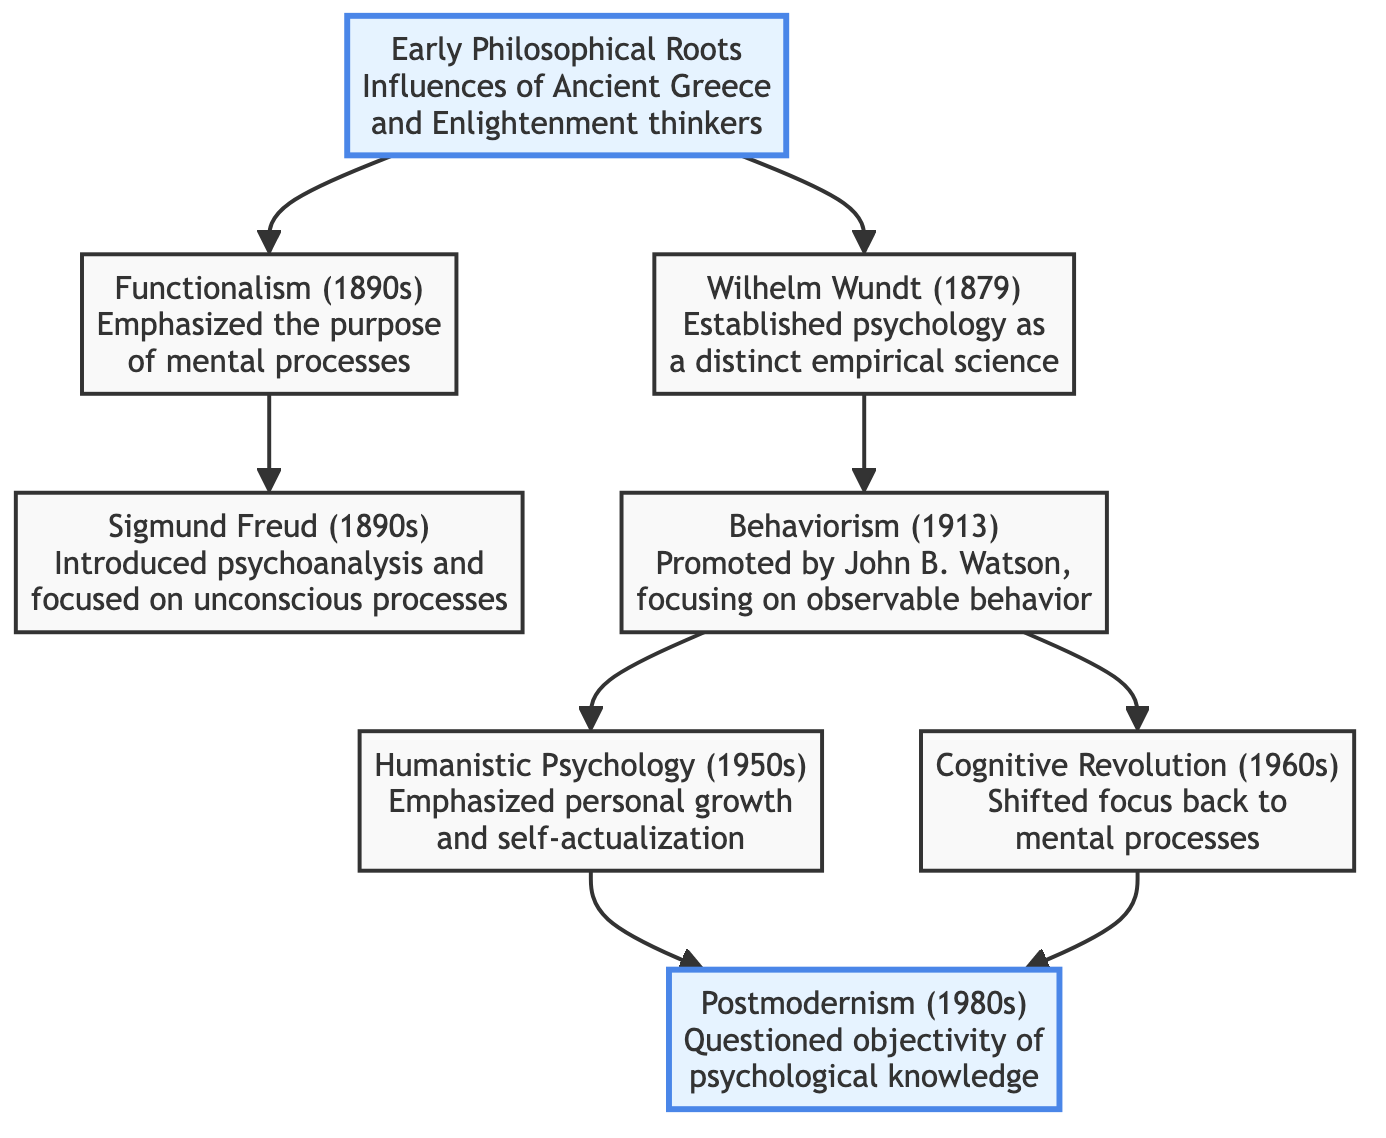What are the two branches stemming from Early Philosophical Roots? The diagram shows two edges coming out of the node "Early Philosophical Roots," connecting to the nodes "Wilhelm Wundt (1879)" and "Functionalism (1890s)."
Answer: Wilhelm Wundt (1879), Functionalism (1890s) How many nodes are there in the diagram? By counting the individual nodes listed in the diagram, we find a total of 8 distinct nodes: Early Philosophical Roots, Wilhelm Wundt, Functionalism, Sigmund Freud, Behaviorism, Humanistic Psychology, Cognitive Revolution, and Postmodernism.
Answer: 8 Which psychological movement follows Behaviorism directly? The edge from the node "Behaviorism (1913)" points to two nodes: "Humanistic Psychology (1950s)" and "Cognitive Revolution (1960s)." Both represent movements that came after Behaviorism; however, Humanistic Psychology is listed first in the diagram, making it the immediate subsequent movement.
Answer: Humanistic Psychology (1950s) What key shift did the Cognitive Revolution represent compared to Behaviorism? The Cognitive Revolution marked a return to focusing on mental processes, contrasting with Behaviorism, which emphasized only observable behavior. The connection from Behaviorism to the Cognitive Revolution indicates this shift in focus.
Answer: Focus on mental processes What is the relationship between Functionalism and Sigmund Freud? According to the diagram, "Functionalism (1890s)" directs to "Sigmund Freud (1890s)" showing that Functionalism influenced Freud's development of psychoanalysis, which relates more broadly to the themes of mental processes and unconscious thoughts.
Answer: Influence How does the Humanistic Psychology node connect to Postmodernism? The node for Humanistic Psychology (1950s) has a direct edge leading to Postmodernism (1980s), indicating a developmental relation, showing that discussions around personal growth influenced later debates on cultural context and objectivity in psychology.
Answer: Directly connected Which theorist's work established psychology as an empirical science? The node "Wilhelm Wundt (1879)" explicitly states that he established psychology as a distinct empirical science, thus answering the question regarding who was pivotal in this foundational aspect.
Answer: Wilhelm Wundt How many connections (edges) are there in total in the graph? Counting the edges shown in the diagram, there are a total of 8 connections represented, indicating the relationships between the different nodes (the historical developments in psychology).
Answer: 8 